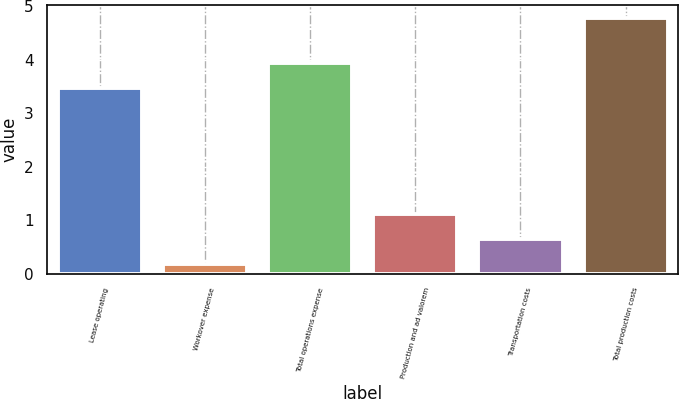<chart> <loc_0><loc_0><loc_500><loc_500><bar_chart><fcel>Lease operating<fcel>Workover expense<fcel>Total operations expense<fcel>Production and ad valorem<fcel>Transportation costs<fcel>Total production costs<nl><fcel>3.47<fcel>0.19<fcel>3.93<fcel>1.11<fcel>0.65<fcel>4.78<nl></chart> 